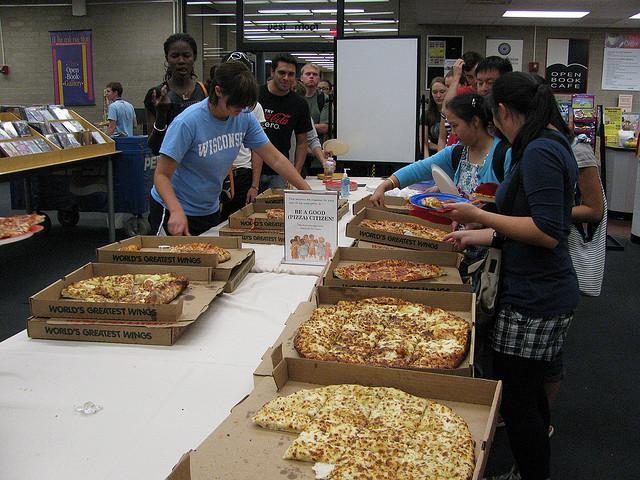How many pizzas are visible?
Give a very brief answer. 3. How many people can you see?
Give a very brief answer. 6. How many dining tables are visible?
Give a very brief answer. 2. How many handbags are visible?
Give a very brief answer. 2. How many boats are in the water?
Give a very brief answer. 0. 